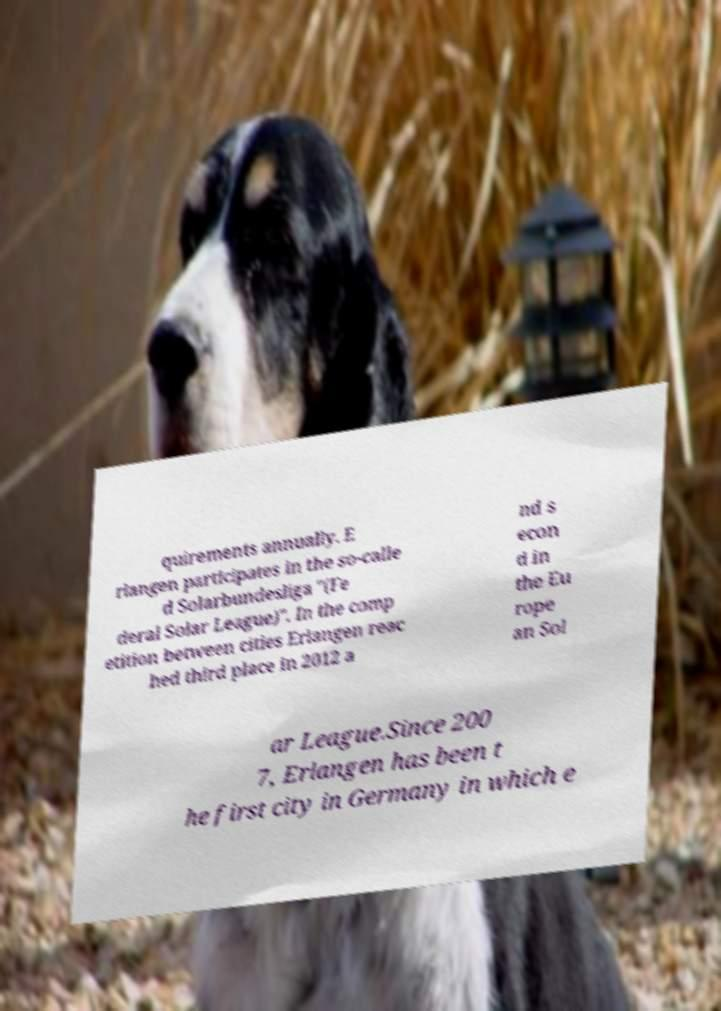For documentation purposes, I need the text within this image transcribed. Could you provide that? quirements annually. E rlangen participates in the so-calle d Solarbundesliga "(Fe deral Solar League)". In the comp etition between cities Erlangen reac hed third place in 2012 a nd s econ d in the Eu rope an Sol ar League.Since 200 7, Erlangen has been t he first city in Germany in which e 